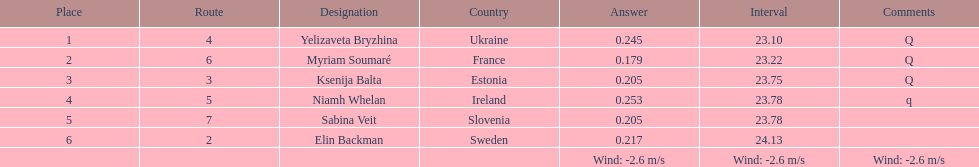How long did it take elin backman to finish the race? 24.13. 